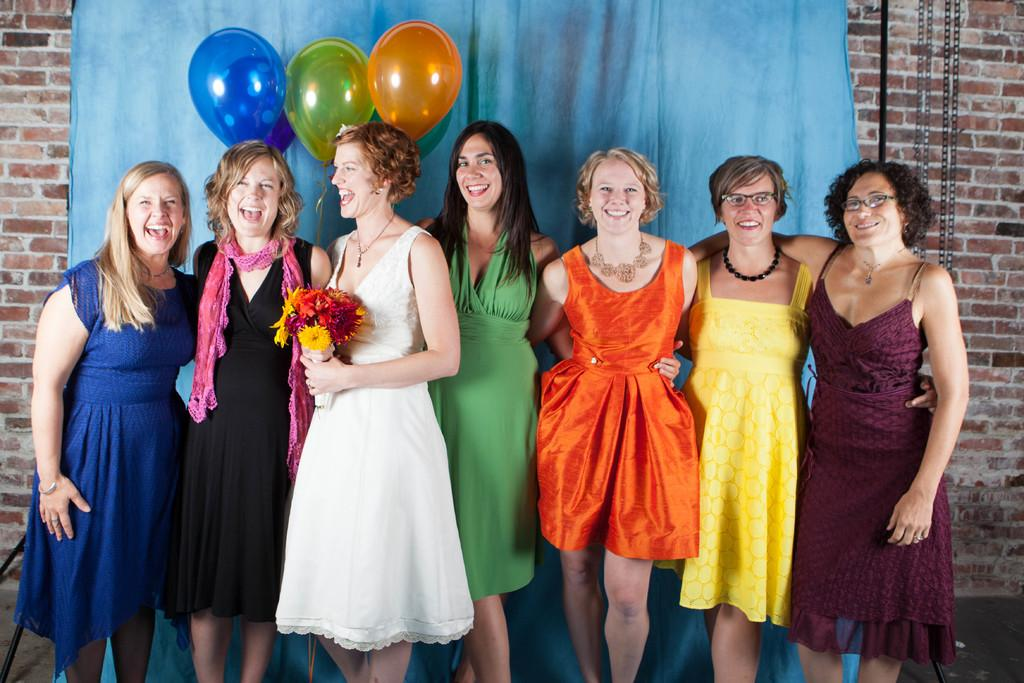What are the people in the image doing? The people in the image are standing in the center. Can you describe what the woman is holding? The woman is holding a flower bouquet. What can be seen in the background of the image? There is a wall, a curtain, balloons, and chains visible in the background. What type of oil is being used in the fight scene in the image? There is no fight scene or oil present in the image. What kind of show is being performed in the image? There is no show being performed in the image; it simply shows people standing and a woman holding a flower bouquet. 